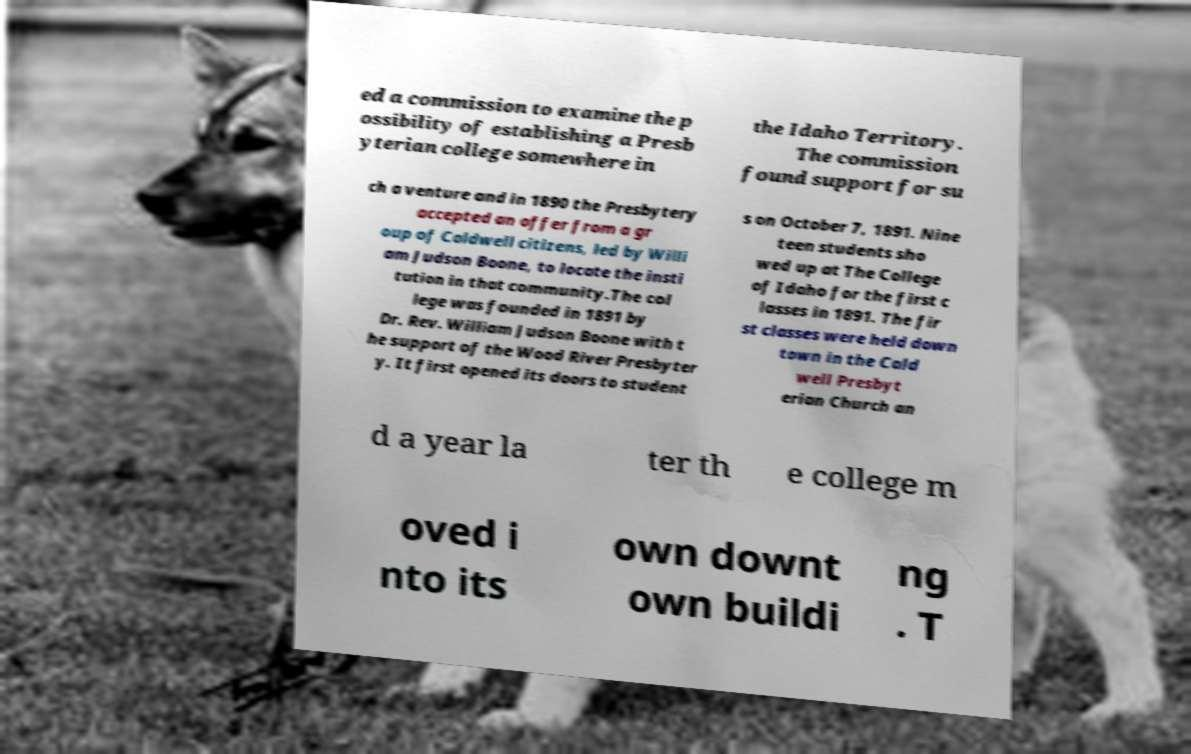Please read and relay the text visible in this image. What does it say? ed a commission to examine the p ossibility of establishing a Presb yterian college somewhere in the Idaho Territory. The commission found support for su ch a venture and in 1890 the Presbytery accepted an offer from a gr oup of Caldwell citizens, led by Willi am Judson Boone, to locate the insti tution in that community.The col lege was founded in 1891 by Dr. Rev. William Judson Boone with t he support of the Wood River Presbyter y. It first opened its doors to student s on October 7, 1891. Nine teen students sho wed up at The College of Idaho for the first c lasses in 1891. The fir st classes were held down town in the Cald well Presbyt erian Church an d a year la ter th e college m oved i nto its own downt own buildi ng . T 